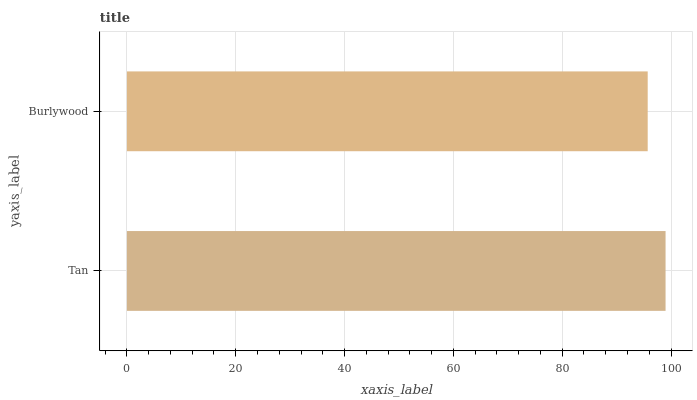Is Burlywood the minimum?
Answer yes or no. Yes. Is Tan the maximum?
Answer yes or no. Yes. Is Burlywood the maximum?
Answer yes or no. No. Is Tan greater than Burlywood?
Answer yes or no. Yes. Is Burlywood less than Tan?
Answer yes or no. Yes. Is Burlywood greater than Tan?
Answer yes or no. No. Is Tan less than Burlywood?
Answer yes or no. No. Is Tan the high median?
Answer yes or no. Yes. Is Burlywood the low median?
Answer yes or no. Yes. Is Burlywood the high median?
Answer yes or no. No. Is Tan the low median?
Answer yes or no. No. 